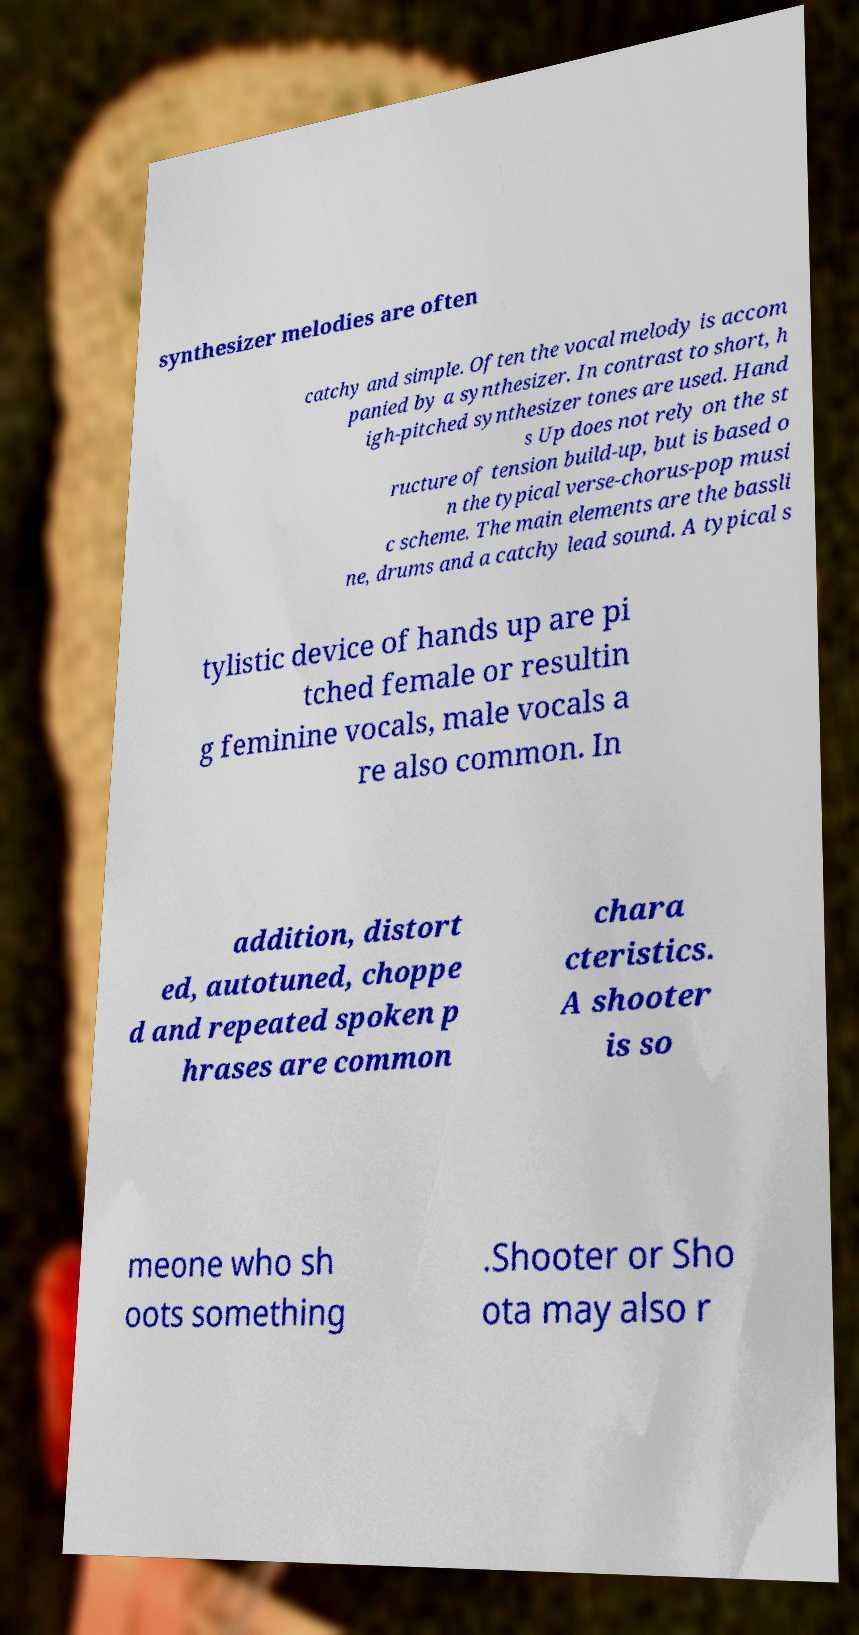Please read and relay the text visible in this image. What does it say? synthesizer melodies are often catchy and simple. Often the vocal melody is accom panied by a synthesizer. In contrast to short, h igh-pitched synthesizer tones are used. Hand s Up does not rely on the st ructure of tension build-up, but is based o n the typical verse-chorus-pop musi c scheme. The main elements are the bassli ne, drums and a catchy lead sound. A typical s tylistic device of hands up are pi tched female or resultin g feminine vocals, male vocals a re also common. In addition, distort ed, autotuned, choppe d and repeated spoken p hrases are common chara cteristics. A shooter is so meone who sh oots something .Shooter or Sho ota may also r 